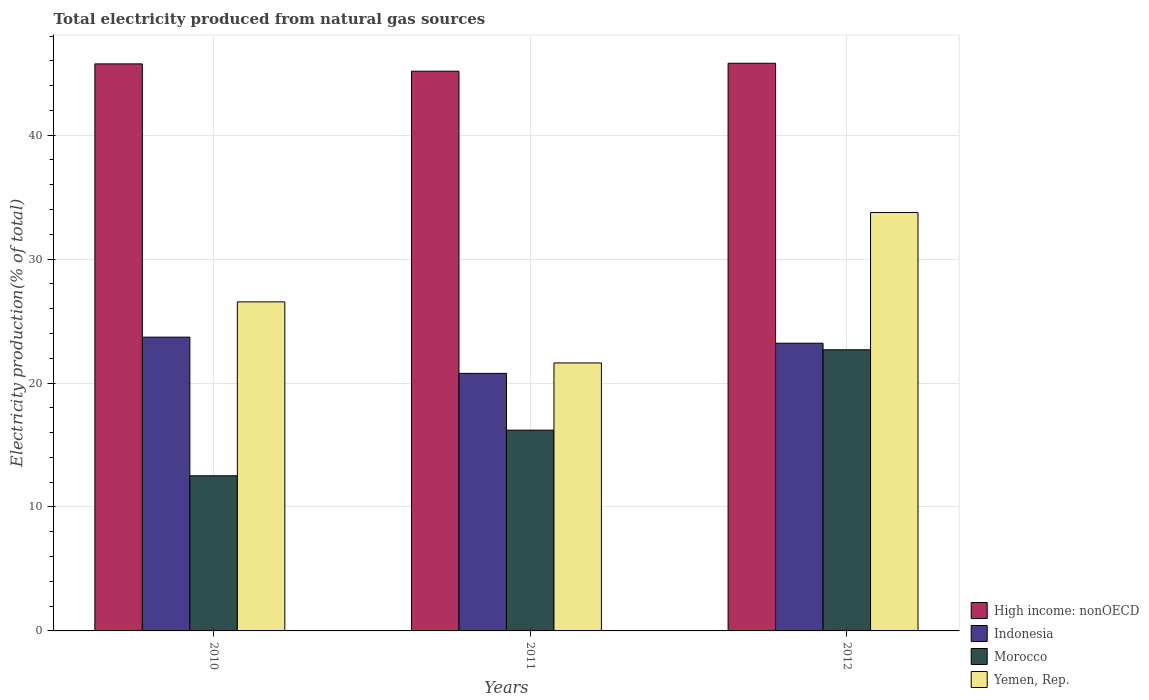How many different coloured bars are there?
Make the answer very short. 4. How many groups of bars are there?
Ensure brevity in your answer.  3. Are the number of bars per tick equal to the number of legend labels?
Your answer should be compact. Yes. What is the label of the 2nd group of bars from the left?
Offer a terse response. 2011. In how many cases, is the number of bars for a given year not equal to the number of legend labels?
Ensure brevity in your answer.  0. What is the total electricity produced in Morocco in 2011?
Provide a succinct answer. 16.2. Across all years, what is the maximum total electricity produced in Yemen, Rep.?
Provide a succinct answer. 33.76. Across all years, what is the minimum total electricity produced in Indonesia?
Your answer should be compact. 20.78. In which year was the total electricity produced in Morocco maximum?
Keep it short and to the point. 2012. What is the total total electricity produced in Indonesia in the graph?
Provide a short and direct response. 67.7. What is the difference between the total electricity produced in Yemen, Rep. in 2011 and that in 2012?
Your answer should be very brief. -12.13. What is the difference between the total electricity produced in Morocco in 2010 and the total electricity produced in Yemen, Rep. in 2012?
Provide a short and direct response. -21.24. What is the average total electricity produced in Indonesia per year?
Offer a terse response. 22.57. In the year 2010, what is the difference between the total electricity produced in Indonesia and total electricity produced in Morocco?
Ensure brevity in your answer.  11.19. In how many years, is the total electricity produced in Yemen, Rep. greater than 36 %?
Your answer should be compact. 0. What is the ratio of the total electricity produced in Morocco in 2010 to that in 2012?
Ensure brevity in your answer.  0.55. Is the total electricity produced in Yemen, Rep. in 2010 less than that in 2011?
Your answer should be very brief. No. Is the difference between the total electricity produced in Indonesia in 2010 and 2011 greater than the difference between the total electricity produced in Morocco in 2010 and 2011?
Offer a terse response. Yes. What is the difference between the highest and the second highest total electricity produced in High income: nonOECD?
Your answer should be very brief. 0.05. What is the difference between the highest and the lowest total electricity produced in Yemen, Rep.?
Give a very brief answer. 12.13. Is it the case that in every year, the sum of the total electricity produced in Yemen, Rep. and total electricity produced in High income: nonOECD is greater than the sum of total electricity produced in Indonesia and total electricity produced in Morocco?
Make the answer very short. Yes. What does the 1st bar from the left in 2012 represents?
Make the answer very short. High income: nonOECD. Are all the bars in the graph horizontal?
Provide a short and direct response. No. How many years are there in the graph?
Your answer should be very brief. 3. Does the graph contain any zero values?
Keep it short and to the point. No. How are the legend labels stacked?
Your response must be concise. Vertical. What is the title of the graph?
Provide a short and direct response. Total electricity produced from natural gas sources. What is the label or title of the X-axis?
Your answer should be compact. Years. What is the label or title of the Y-axis?
Your response must be concise. Electricity production(% of total). What is the Electricity production(% of total) of High income: nonOECD in 2010?
Ensure brevity in your answer.  45.75. What is the Electricity production(% of total) of Indonesia in 2010?
Your response must be concise. 23.7. What is the Electricity production(% of total) in Morocco in 2010?
Offer a very short reply. 12.52. What is the Electricity production(% of total) in Yemen, Rep. in 2010?
Provide a succinct answer. 26.55. What is the Electricity production(% of total) in High income: nonOECD in 2011?
Your answer should be compact. 45.16. What is the Electricity production(% of total) in Indonesia in 2011?
Offer a terse response. 20.78. What is the Electricity production(% of total) in Morocco in 2011?
Your answer should be compact. 16.2. What is the Electricity production(% of total) in Yemen, Rep. in 2011?
Ensure brevity in your answer.  21.62. What is the Electricity production(% of total) in High income: nonOECD in 2012?
Offer a very short reply. 45.8. What is the Electricity production(% of total) in Indonesia in 2012?
Your answer should be very brief. 23.22. What is the Electricity production(% of total) of Morocco in 2012?
Provide a short and direct response. 22.69. What is the Electricity production(% of total) of Yemen, Rep. in 2012?
Ensure brevity in your answer.  33.76. Across all years, what is the maximum Electricity production(% of total) in High income: nonOECD?
Keep it short and to the point. 45.8. Across all years, what is the maximum Electricity production(% of total) in Indonesia?
Provide a short and direct response. 23.7. Across all years, what is the maximum Electricity production(% of total) in Morocco?
Ensure brevity in your answer.  22.69. Across all years, what is the maximum Electricity production(% of total) of Yemen, Rep.?
Ensure brevity in your answer.  33.76. Across all years, what is the minimum Electricity production(% of total) of High income: nonOECD?
Provide a succinct answer. 45.16. Across all years, what is the minimum Electricity production(% of total) of Indonesia?
Make the answer very short. 20.78. Across all years, what is the minimum Electricity production(% of total) of Morocco?
Offer a very short reply. 12.52. Across all years, what is the minimum Electricity production(% of total) of Yemen, Rep.?
Ensure brevity in your answer.  21.62. What is the total Electricity production(% of total) of High income: nonOECD in the graph?
Make the answer very short. 136.72. What is the total Electricity production(% of total) in Indonesia in the graph?
Your answer should be compact. 67.7. What is the total Electricity production(% of total) in Morocco in the graph?
Ensure brevity in your answer.  51.4. What is the total Electricity production(% of total) of Yemen, Rep. in the graph?
Your response must be concise. 81.93. What is the difference between the Electricity production(% of total) of High income: nonOECD in 2010 and that in 2011?
Your answer should be compact. 0.59. What is the difference between the Electricity production(% of total) in Indonesia in 2010 and that in 2011?
Your answer should be very brief. 2.92. What is the difference between the Electricity production(% of total) in Morocco in 2010 and that in 2011?
Provide a short and direct response. -3.68. What is the difference between the Electricity production(% of total) of Yemen, Rep. in 2010 and that in 2011?
Your response must be concise. 4.93. What is the difference between the Electricity production(% of total) in High income: nonOECD in 2010 and that in 2012?
Make the answer very short. -0.05. What is the difference between the Electricity production(% of total) in Indonesia in 2010 and that in 2012?
Make the answer very short. 0.49. What is the difference between the Electricity production(% of total) of Morocco in 2010 and that in 2012?
Offer a terse response. -10.17. What is the difference between the Electricity production(% of total) of Yemen, Rep. in 2010 and that in 2012?
Offer a terse response. -7.21. What is the difference between the Electricity production(% of total) of High income: nonOECD in 2011 and that in 2012?
Provide a short and direct response. -0.64. What is the difference between the Electricity production(% of total) of Indonesia in 2011 and that in 2012?
Ensure brevity in your answer.  -2.43. What is the difference between the Electricity production(% of total) in Morocco in 2011 and that in 2012?
Offer a terse response. -6.49. What is the difference between the Electricity production(% of total) in Yemen, Rep. in 2011 and that in 2012?
Offer a very short reply. -12.13. What is the difference between the Electricity production(% of total) of High income: nonOECD in 2010 and the Electricity production(% of total) of Indonesia in 2011?
Ensure brevity in your answer.  24.97. What is the difference between the Electricity production(% of total) in High income: nonOECD in 2010 and the Electricity production(% of total) in Morocco in 2011?
Offer a terse response. 29.55. What is the difference between the Electricity production(% of total) of High income: nonOECD in 2010 and the Electricity production(% of total) of Yemen, Rep. in 2011?
Keep it short and to the point. 24.13. What is the difference between the Electricity production(% of total) of Indonesia in 2010 and the Electricity production(% of total) of Morocco in 2011?
Your answer should be compact. 7.5. What is the difference between the Electricity production(% of total) in Indonesia in 2010 and the Electricity production(% of total) in Yemen, Rep. in 2011?
Keep it short and to the point. 2.08. What is the difference between the Electricity production(% of total) of Morocco in 2010 and the Electricity production(% of total) of Yemen, Rep. in 2011?
Offer a terse response. -9.11. What is the difference between the Electricity production(% of total) of High income: nonOECD in 2010 and the Electricity production(% of total) of Indonesia in 2012?
Your response must be concise. 22.54. What is the difference between the Electricity production(% of total) of High income: nonOECD in 2010 and the Electricity production(% of total) of Morocco in 2012?
Your response must be concise. 23.07. What is the difference between the Electricity production(% of total) in High income: nonOECD in 2010 and the Electricity production(% of total) in Yemen, Rep. in 2012?
Your response must be concise. 11.99. What is the difference between the Electricity production(% of total) in Indonesia in 2010 and the Electricity production(% of total) in Morocco in 2012?
Offer a very short reply. 1.02. What is the difference between the Electricity production(% of total) of Indonesia in 2010 and the Electricity production(% of total) of Yemen, Rep. in 2012?
Give a very brief answer. -10.05. What is the difference between the Electricity production(% of total) in Morocco in 2010 and the Electricity production(% of total) in Yemen, Rep. in 2012?
Your response must be concise. -21.24. What is the difference between the Electricity production(% of total) in High income: nonOECD in 2011 and the Electricity production(% of total) in Indonesia in 2012?
Keep it short and to the point. 21.95. What is the difference between the Electricity production(% of total) of High income: nonOECD in 2011 and the Electricity production(% of total) of Morocco in 2012?
Make the answer very short. 22.48. What is the difference between the Electricity production(% of total) of High income: nonOECD in 2011 and the Electricity production(% of total) of Yemen, Rep. in 2012?
Your answer should be compact. 11.4. What is the difference between the Electricity production(% of total) of Indonesia in 2011 and the Electricity production(% of total) of Morocco in 2012?
Provide a succinct answer. -1.9. What is the difference between the Electricity production(% of total) in Indonesia in 2011 and the Electricity production(% of total) in Yemen, Rep. in 2012?
Provide a succinct answer. -12.98. What is the difference between the Electricity production(% of total) in Morocco in 2011 and the Electricity production(% of total) in Yemen, Rep. in 2012?
Keep it short and to the point. -17.56. What is the average Electricity production(% of total) in High income: nonOECD per year?
Keep it short and to the point. 45.57. What is the average Electricity production(% of total) in Indonesia per year?
Your response must be concise. 22.57. What is the average Electricity production(% of total) of Morocco per year?
Your answer should be compact. 17.13. What is the average Electricity production(% of total) of Yemen, Rep. per year?
Offer a very short reply. 27.31. In the year 2010, what is the difference between the Electricity production(% of total) in High income: nonOECD and Electricity production(% of total) in Indonesia?
Offer a terse response. 22.05. In the year 2010, what is the difference between the Electricity production(% of total) of High income: nonOECD and Electricity production(% of total) of Morocco?
Give a very brief answer. 33.24. In the year 2010, what is the difference between the Electricity production(% of total) in High income: nonOECD and Electricity production(% of total) in Yemen, Rep.?
Provide a succinct answer. 19.2. In the year 2010, what is the difference between the Electricity production(% of total) in Indonesia and Electricity production(% of total) in Morocco?
Ensure brevity in your answer.  11.19. In the year 2010, what is the difference between the Electricity production(% of total) in Indonesia and Electricity production(% of total) in Yemen, Rep.?
Your answer should be compact. -2.85. In the year 2010, what is the difference between the Electricity production(% of total) of Morocco and Electricity production(% of total) of Yemen, Rep.?
Your answer should be very brief. -14.03. In the year 2011, what is the difference between the Electricity production(% of total) in High income: nonOECD and Electricity production(% of total) in Indonesia?
Ensure brevity in your answer.  24.38. In the year 2011, what is the difference between the Electricity production(% of total) of High income: nonOECD and Electricity production(% of total) of Morocco?
Give a very brief answer. 28.96. In the year 2011, what is the difference between the Electricity production(% of total) of High income: nonOECD and Electricity production(% of total) of Yemen, Rep.?
Your response must be concise. 23.54. In the year 2011, what is the difference between the Electricity production(% of total) of Indonesia and Electricity production(% of total) of Morocco?
Provide a short and direct response. 4.58. In the year 2011, what is the difference between the Electricity production(% of total) in Indonesia and Electricity production(% of total) in Yemen, Rep.?
Your answer should be very brief. -0.84. In the year 2011, what is the difference between the Electricity production(% of total) in Morocco and Electricity production(% of total) in Yemen, Rep.?
Keep it short and to the point. -5.42. In the year 2012, what is the difference between the Electricity production(% of total) in High income: nonOECD and Electricity production(% of total) in Indonesia?
Your answer should be very brief. 22.59. In the year 2012, what is the difference between the Electricity production(% of total) in High income: nonOECD and Electricity production(% of total) in Morocco?
Offer a terse response. 23.12. In the year 2012, what is the difference between the Electricity production(% of total) in High income: nonOECD and Electricity production(% of total) in Yemen, Rep.?
Keep it short and to the point. 12.05. In the year 2012, what is the difference between the Electricity production(% of total) in Indonesia and Electricity production(% of total) in Morocco?
Offer a terse response. 0.53. In the year 2012, what is the difference between the Electricity production(% of total) of Indonesia and Electricity production(% of total) of Yemen, Rep.?
Keep it short and to the point. -10.54. In the year 2012, what is the difference between the Electricity production(% of total) in Morocco and Electricity production(% of total) in Yemen, Rep.?
Your response must be concise. -11.07. What is the ratio of the Electricity production(% of total) in High income: nonOECD in 2010 to that in 2011?
Your answer should be compact. 1.01. What is the ratio of the Electricity production(% of total) in Indonesia in 2010 to that in 2011?
Make the answer very short. 1.14. What is the ratio of the Electricity production(% of total) in Morocco in 2010 to that in 2011?
Your answer should be compact. 0.77. What is the ratio of the Electricity production(% of total) of Yemen, Rep. in 2010 to that in 2011?
Your answer should be very brief. 1.23. What is the ratio of the Electricity production(% of total) of High income: nonOECD in 2010 to that in 2012?
Your answer should be compact. 1. What is the ratio of the Electricity production(% of total) of Indonesia in 2010 to that in 2012?
Offer a very short reply. 1.02. What is the ratio of the Electricity production(% of total) in Morocco in 2010 to that in 2012?
Give a very brief answer. 0.55. What is the ratio of the Electricity production(% of total) in Yemen, Rep. in 2010 to that in 2012?
Offer a terse response. 0.79. What is the ratio of the Electricity production(% of total) in Indonesia in 2011 to that in 2012?
Your answer should be compact. 0.9. What is the ratio of the Electricity production(% of total) of Morocco in 2011 to that in 2012?
Provide a succinct answer. 0.71. What is the ratio of the Electricity production(% of total) of Yemen, Rep. in 2011 to that in 2012?
Ensure brevity in your answer.  0.64. What is the difference between the highest and the second highest Electricity production(% of total) in High income: nonOECD?
Give a very brief answer. 0.05. What is the difference between the highest and the second highest Electricity production(% of total) of Indonesia?
Keep it short and to the point. 0.49. What is the difference between the highest and the second highest Electricity production(% of total) in Morocco?
Your answer should be very brief. 6.49. What is the difference between the highest and the second highest Electricity production(% of total) of Yemen, Rep.?
Ensure brevity in your answer.  7.21. What is the difference between the highest and the lowest Electricity production(% of total) of High income: nonOECD?
Your response must be concise. 0.64. What is the difference between the highest and the lowest Electricity production(% of total) in Indonesia?
Give a very brief answer. 2.92. What is the difference between the highest and the lowest Electricity production(% of total) in Morocco?
Provide a succinct answer. 10.17. What is the difference between the highest and the lowest Electricity production(% of total) in Yemen, Rep.?
Provide a succinct answer. 12.13. 